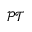<formula> <loc_0><loc_0><loc_500><loc_500>\mathcal { P T }</formula> 